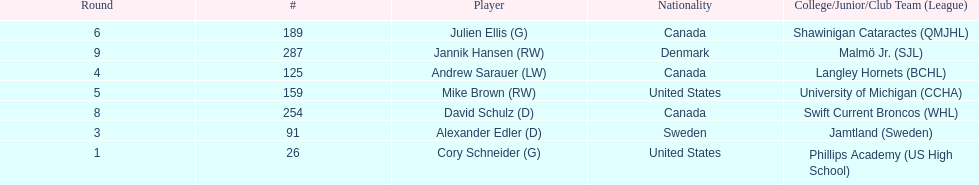How many goalies drafted? 2. 